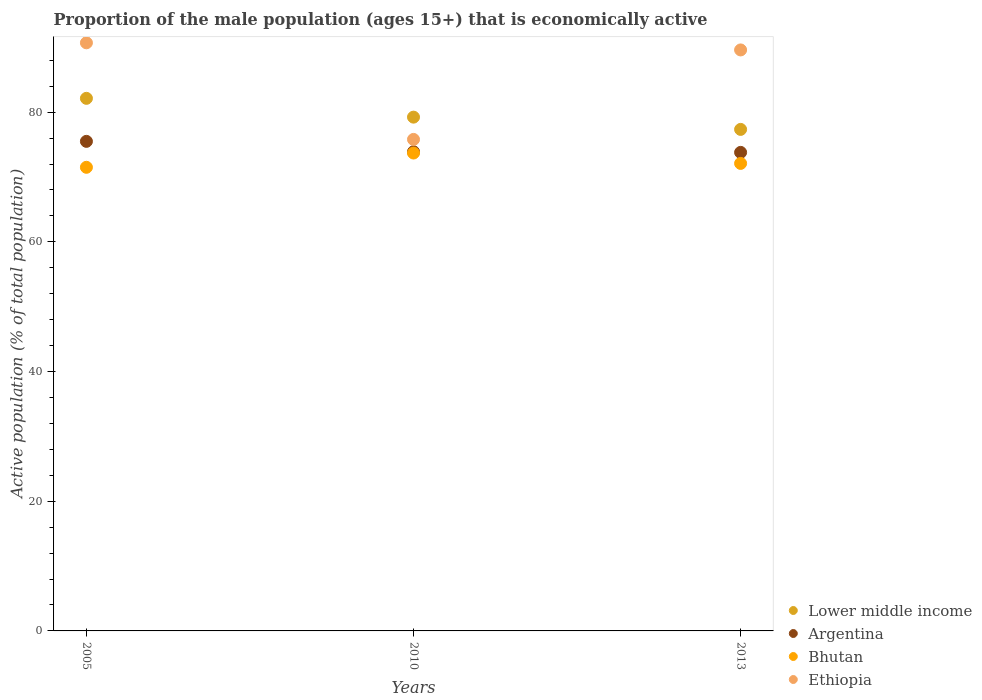What is the proportion of the male population that is economically active in Argentina in 2005?
Make the answer very short. 75.5. Across all years, what is the maximum proportion of the male population that is economically active in Bhutan?
Your response must be concise. 73.7. Across all years, what is the minimum proportion of the male population that is economically active in Lower middle income?
Keep it short and to the point. 77.34. In which year was the proportion of the male population that is economically active in Argentina minimum?
Offer a very short reply. 2013. What is the total proportion of the male population that is economically active in Argentina in the graph?
Ensure brevity in your answer.  223.2. What is the difference between the proportion of the male population that is economically active in Ethiopia in 2005 and that in 2013?
Provide a short and direct response. 1.1. What is the difference between the proportion of the male population that is economically active in Bhutan in 2013 and the proportion of the male population that is economically active in Lower middle income in 2005?
Your response must be concise. -10.03. What is the average proportion of the male population that is economically active in Ethiopia per year?
Offer a very short reply. 85.37. In the year 2005, what is the difference between the proportion of the male population that is economically active in Ethiopia and proportion of the male population that is economically active in Bhutan?
Keep it short and to the point. 19.2. In how many years, is the proportion of the male population that is economically active in Bhutan greater than 80 %?
Give a very brief answer. 0. What is the ratio of the proportion of the male population that is economically active in Lower middle income in 2005 to that in 2010?
Keep it short and to the point. 1.04. What is the difference between the highest and the second highest proportion of the male population that is economically active in Lower middle income?
Your answer should be very brief. 2.9. What is the difference between the highest and the lowest proportion of the male population that is economically active in Lower middle income?
Keep it short and to the point. 4.79. In how many years, is the proportion of the male population that is economically active in Bhutan greater than the average proportion of the male population that is economically active in Bhutan taken over all years?
Offer a very short reply. 1. Is it the case that in every year, the sum of the proportion of the male population that is economically active in Ethiopia and proportion of the male population that is economically active in Argentina  is greater than the sum of proportion of the male population that is economically active in Lower middle income and proportion of the male population that is economically active in Bhutan?
Provide a short and direct response. Yes. Is it the case that in every year, the sum of the proportion of the male population that is economically active in Ethiopia and proportion of the male population that is economically active in Lower middle income  is greater than the proportion of the male population that is economically active in Bhutan?
Provide a short and direct response. Yes. Is the proportion of the male population that is economically active in Argentina strictly greater than the proportion of the male population that is economically active in Bhutan over the years?
Your answer should be compact. Yes. Is the proportion of the male population that is economically active in Ethiopia strictly less than the proportion of the male population that is economically active in Lower middle income over the years?
Ensure brevity in your answer.  No. How many dotlines are there?
Give a very brief answer. 4. Where does the legend appear in the graph?
Keep it short and to the point. Bottom right. How many legend labels are there?
Offer a terse response. 4. How are the legend labels stacked?
Provide a short and direct response. Vertical. What is the title of the graph?
Your response must be concise. Proportion of the male population (ages 15+) that is economically active. What is the label or title of the Y-axis?
Give a very brief answer. Active population (% of total population). What is the Active population (% of total population) in Lower middle income in 2005?
Your answer should be very brief. 82.13. What is the Active population (% of total population) in Argentina in 2005?
Your answer should be very brief. 75.5. What is the Active population (% of total population) in Bhutan in 2005?
Ensure brevity in your answer.  71.5. What is the Active population (% of total population) of Ethiopia in 2005?
Provide a succinct answer. 90.7. What is the Active population (% of total population) in Lower middle income in 2010?
Offer a terse response. 79.24. What is the Active population (% of total population) in Argentina in 2010?
Your response must be concise. 73.9. What is the Active population (% of total population) in Bhutan in 2010?
Your answer should be very brief. 73.7. What is the Active population (% of total population) of Ethiopia in 2010?
Ensure brevity in your answer.  75.8. What is the Active population (% of total population) of Lower middle income in 2013?
Provide a succinct answer. 77.34. What is the Active population (% of total population) of Argentina in 2013?
Ensure brevity in your answer.  73.8. What is the Active population (% of total population) in Bhutan in 2013?
Your answer should be compact. 72.1. What is the Active population (% of total population) in Ethiopia in 2013?
Your answer should be very brief. 89.6. Across all years, what is the maximum Active population (% of total population) of Lower middle income?
Your answer should be very brief. 82.13. Across all years, what is the maximum Active population (% of total population) of Argentina?
Offer a terse response. 75.5. Across all years, what is the maximum Active population (% of total population) in Bhutan?
Your response must be concise. 73.7. Across all years, what is the maximum Active population (% of total population) in Ethiopia?
Your response must be concise. 90.7. Across all years, what is the minimum Active population (% of total population) of Lower middle income?
Your response must be concise. 77.34. Across all years, what is the minimum Active population (% of total population) in Argentina?
Provide a succinct answer. 73.8. Across all years, what is the minimum Active population (% of total population) of Bhutan?
Give a very brief answer. 71.5. Across all years, what is the minimum Active population (% of total population) in Ethiopia?
Make the answer very short. 75.8. What is the total Active population (% of total population) in Lower middle income in the graph?
Offer a terse response. 238.71. What is the total Active population (% of total population) of Argentina in the graph?
Your answer should be very brief. 223.2. What is the total Active population (% of total population) in Bhutan in the graph?
Offer a very short reply. 217.3. What is the total Active population (% of total population) of Ethiopia in the graph?
Provide a short and direct response. 256.1. What is the difference between the Active population (% of total population) in Lower middle income in 2005 and that in 2010?
Provide a short and direct response. 2.9. What is the difference between the Active population (% of total population) in Argentina in 2005 and that in 2010?
Your response must be concise. 1.6. What is the difference between the Active population (% of total population) in Lower middle income in 2005 and that in 2013?
Your answer should be compact. 4.79. What is the difference between the Active population (% of total population) in Bhutan in 2005 and that in 2013?
Provide a short and direct response. -0.6. What is the difference between the Active population (% of total population) in Lower middle income in 2010 and that in 2013?
Provide a succinct answer. 1.89. What is the difference between the Active population (% of total population) of Lower middle income in 2005 and the Active population (% of total population) of Argentina in 2010?
Your answer should be very brief. 8.23. What is the difference between the Active population (% of total population) in Lower middle income in 2005 and the Active population (% of total population) in Bhutan in 2010?
Ensure brevity in your answer.  8.43. What is the difference between the Active population (% of total population) in Lower middle income in 2005 and the Active population (% of total population) in Ethiopia in 2010?
Your answer should be very brief. 6.33. What is the difference between the Active population (% of total population) of Lower middle income in 2005 and the Active population (% of total population) of Argentina in 2013?
Offer a very short reply. 8.33. What is the difference between the Active population (% of total population) in Lower middle income in 2005 and the Active population (% of total population) in Bhutan in 2013?
Provide a succinct answer. 10.03. What is the difference between the Active population (% of total population) of Lower middle income in 2005 and the Active population (% of total population) of Ethiopia in 2013?
Your answer should be very brief. -7.47. What is the difference between the Active population (% of total population) in Argentina in 2005 and the Active population (% of total population) in Ethiopia in 2013?
Provide a succinct answer. -14.1. What is the difference between the Active population (% of total population) of Bhutan in 2005 and the Active population (% of total population) of Ethiopia in 2013?
Your response must be concise. -18.1. What is the difference between the Active population (% of total population) of Lower middle income in 2010 and the Active population (% of total population) of Argentina in 2013?
Provide a short and direct response. 5.43. What is the difference between the Active population (% of total population) of Lower middle income in 2010 and the Active population (% of total population) of Bhutan in 2013?
Provide a succinct answer. 7.13. What is the difference between the Active population (% of total population) of Lower middle income in 2010 and the Active population (% of total population) of Ethiopia in 2013?
Keep it short and to the point. -10.37. What is the difference between the Active population (% of total population) of Argentina in 2010 and the Active population (% of total population) of Ethiopia in 2013?
Provide a succinct answer. -15.7. What is the difference between the Active population (% of total population) in Bhutan in 2010 and the Active population (% of total population) in Ethiopia in 2013?
Make the answer very short. -15.9. What is the average Active population (% of total population) of Lower middle income per year?
Give a very brief answer. 79.57. What is the average Active population (% of total population) in Argentina per year?
Keep it short and to the point. 74.4. What is the average Active population (% of total population) of Bhutan per year?
Provide a short and direct response. 72.43. What is the average Active population (% of total population) in Ethiopia per year?
Provide a short and direct response. 85.37. In the year 2005, what is the difference between the Active population (% of total population) in Lower middle income and Active population (% of total population) in Argentina?
Offer a terse response. 6.63. In the year 2005, what is the difference between the Active population (% of total population) of Lower middle income and Active population (% of total population) of Bhutan?
Your answer should be very brief. 10.63. In the year 2005, what is the difference between the Active population (% of total population) in Lower middle income and Active population (% of total population) in Ethiopia?
Your answer should be very brief. -8.57. In the year 2005, what is the difference between the Active population (% of total population) in Argentina and Active population (% of total population) in Bhutan?
Your response must be concise. 4. In the year 2005, what is the difference between the Active population (% of total population) of Argentina and Active population (% of total population) of Ethiopia?
Give a very brief answer. -15.2. In the year 2005, what is the difference between the Active population (% of total population) in Bhutan and Active population (% of total population) in Ethiopia?
Keep it short and to the point. -19.2. In the year 2010, what is the difference between the Active population (% of total population) of Lower middle income and Active population (% of total population) of Argentina?
Provide a succinct answer. 5.33. In the year 2010, what is the difference between the Active population (% of total population) in Lower middle income and Active population (% of total population) in Bhutan?
Offer a very short reply. 5.54. In the year 2010, what is the difference between the Active population (% of total population) of Lower middle income and Active population (% of total population) of Ethiopia?
Your response must be concise. 3.44. In the year 2010, what is the difference between the Active population (% of total population) of Argentina and Active population (% of total population) of Ethiopia?
Give a very brief answer. -1.9. In the year 2013, what is the difference between the Active population (% of total population) of Lower middle income and Active population (% of total population) of Argentina?
Provide a succinct answer. 3.54. In the year 2013, what is the difference between the Active population (% of total population) in Lower middle income and Active population (% of total population) in Bhutan?
Provide a short and direct response. 5.24. In the year 2013, what is the difference between the Active population (% of total population) in Lower middle income and Active population (% of total population) in Ethiopia?
Provide a short and direct response. -12.26. In the year 2013, what is the difference between the Active population (% of total population) in Argentina and Active population (% of total population) in Bhutan?
Make the answer very short. 1.7. In the year 2013, what is the difference between the Active population (% of total population) of Argentina and Active population (% of total population) of Ethiopia?
Ensure brevity in your answer.  -15.8. In the year 2013, what is the difference between the Active population (% of total population) in Bhutan and Active population (% of total population) in Ethiopia?
Offer a terse response. -17.5. What is the ratio of the Active population (% of total population) in Lower middle income in 2005 to that in 2010?
Ensure brevity in your answer.  1.04. What is the ratio of the Active population (% of total population) in Argentina in 2005 to that in 2010?
Offer a terse response. 1.02. What is the ratio of the Active population (% of total population) of Bhutan in 2005 to that in 2010?
Offer a very short reply. 0.97. What is the ratio of the Active population (% of total population) in Ethiopia in 2005 to that in 2010?
Ensure brevity in your answer.  1.2. What is the ratio of the Active population (% of total population) in Lower middle income in 2005 to that in 2013?
Provide a short and direct response. 1.06. What is the ratio of the Active population (% of total population) of Ethiopia in 2005 to that in 2013?
Ensure brevity in your answer.  1.01. What is the ratio of the Active population (% of total population) of Lower middle income in 2010 to that in 2013?
Provide a succinct answer. 1.02. What is the ratio of the Active population (% of total population) of Argentina in 2010 to that in 2013?
Provide a succinct answer. 1. What is the ratio of the Active population (% of total population) of Bhutan in 2010 to that in 2013?
Keep it short and to the point. 1.02. What is the ratio of the Active population (% of total population) in Ethiopia in 2010 to that in 2013?
Keep it short and to the point. 0.85. What is the difference between the highest and the second highest Active population (% of total population) of Lower middle income?
Your answer should be compact. 2.9. What is the difference between the highest and the second highest Active population (% of total population) in Argentina?
Provide a short and direct response. 1.6. What is the difference between the highest and the second highest Active population (% of total population) of Bhutan?
Offer a terse response. 1.6. What is the difference between the highest and the second highest Active population (% of total population) in Ethiopia?
Keep it short and to the point. 1.1. What is the difference between the highest and the lowest Active population (% of total population) in Lower middle income?
Provide a short and direct response. 4.79. What is the difference between the highest and the lowest Active population (% of total population) in Ethiopia?
Give a very brief answer. 14.9. 